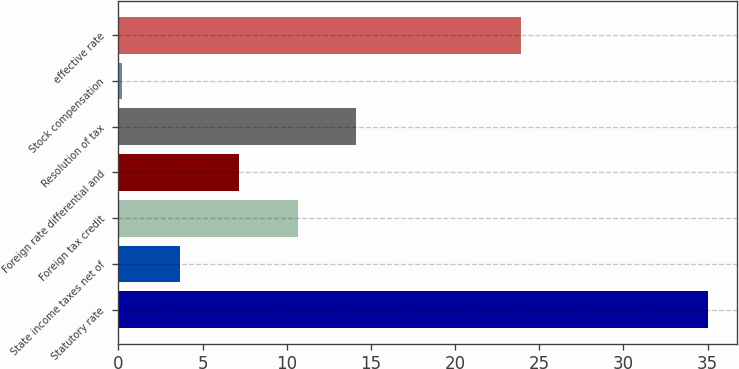<chart> <loc_0><loc_0><loc_500><loc_500><bar_chart><fcel>Statutory rate<fcel>State income taxes net of<fcel>Foreign tax credit<fcel>Foreign rate differential and<fcel>Resolution of tax<fcel>Stock compensation<fcel>effective rate<nl><fcel>35<fcel>3.68<fcel>10.64<fcel>7.16<fcel>14.12<fcel>0.2<fcel>23.9<nl></chart> 